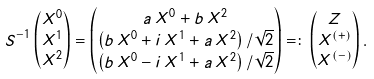Convert formula to latex. <formula><loc_0><loc_0><loc_500><loc_500>& S ^ { - 1 } \begin{pmatrix} X ^ { 0 } \\ X ^ { 1 } \\ X ^ { 2 } \end{pmatrix} = \begin{pmatrix} a \, X ^ { 0 } + b \, X ^ { 2 } \\ \left ( b \, X ^ { 0 } + i \, X ^ { 1 } + a \, X ^ { 2 } \right ) / \sqrt { 2 } \\ \left ( b \, X ^ { 0 } - i \, X ^ { 1 } + a \, X ^ { 2 } \right ) / \sqrt { 2 } \end{pmatrix} = \colon \begin{pmatrix} Z \\ X ^ { ( + ) } \\ X ^ { ( - ) } \end{pmatrix} .</formula> 